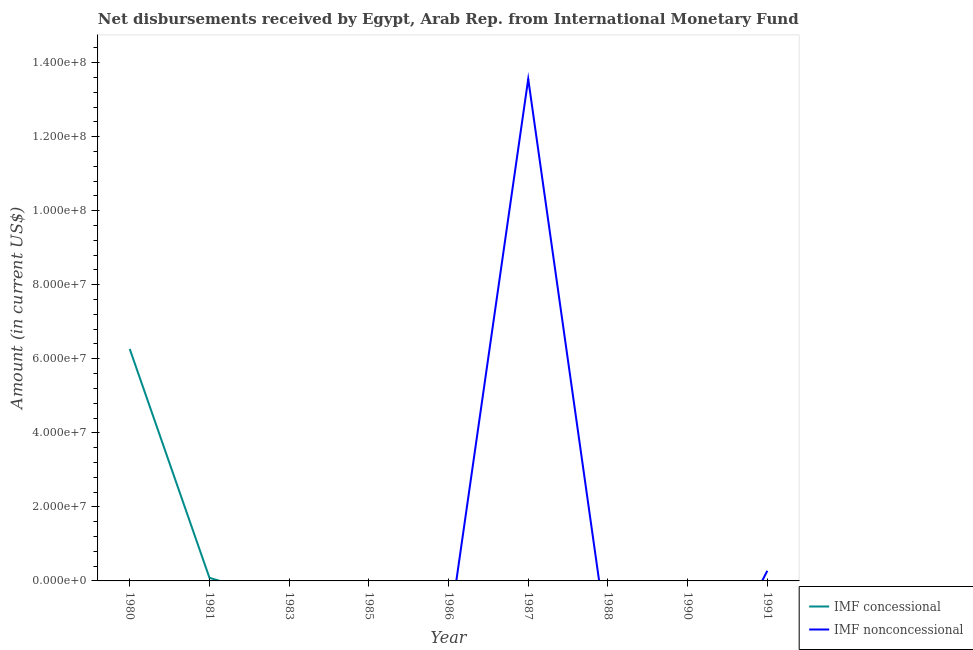Does the line corresponding to net concessional disbursements from imf intersect with the line corresponding to net non concessional disbursements from imf?
Keep it short and to the point. Yes. What is the net non concessional disbursements from imf in 1986?
Ensure brevity in your answer.  0. Across all years, what is the maximum net concessional disbursements from imf?
Your answer should be very brief. 6.26e+07. In which year was the net concessional disbursements from imf maximum?
Your response must be concise. 1980. What is the total net non concessional disbursements from imf in the graph?
Your answer should be compact. 1.38e+08. What is the difference between the net concessional disbursements from imf in 1980 and the net non concessional disbursements from imf in 1990?
Your response must be concise. 6.26e+07. What is the average net concessional disbursements from imf per year?
Your answer should be very brief. 7.05e+06. What is the difference between the highest and the lowest net concessional disbursements from imf?
Offer a very short reply. 6.26e+07. In how many years, is the net non concessional disbursements from imf greater than the average net non concessional disbursements from imf taken over all years?
Provide a short and direct response. 1. Does the net concessional disbursements from imf monotonically increase over the years?
Make the answer very short. No. Is the net concessional disbursements from imf strictly greater than the net non concessional disbursements from imf over the years?
Keep it short and to the point. No. Is the net concessional disbursements from imf strictly less than the net non concessional disbursements from imf over the years?
Provide a succinct answer. No. How many lines are there?
Provide a short and direct response. 2. Does the graph contain any zero values?
Your answer should be compact. Yes. Does the graph contain grids?
Your answer should be compact. No. What is the title of the graph?
Offer a terse response. Net disbursements received by Egypt, Arab Rep. from International Monetary Fund. What is the label or title of the X-axis?
Keep it short and to the point. Year. What is the label or title of the Y-axis?
Offer a very short reply. Amount (in current US$). What is the Amount (in current US$) of IMF concessional in 1980?
Provide a succinct answer. 6.26e+07. What is the Amount (in current US$) in IMF nonconcessional in 1980?
Your response must be concise. 0. What is the Amount (in current US$) of IMF concessional in 1981?
Offer a very short reply. 8.38e+05. What is the Amount (in current US$) in IMF nonconcessional in 1981?
Keep it short and to the point. 0. What is the Amount (in current US$) of IMF concessional in 1983?
Offer a very short reply. 0. What is the Amount (in current US$) in IMF concessional in 1985?
Provide a succinct answer. 0. What is the Amount (in current US$) of IMF concessional in 1986?
Offer a very short reply. 0. What is the Amount (in current US$) in IMF nonconcessional in 1987?
Offer a very short reply. 1.36e+08. What is the Amount (in current US$) of IMF nonconcessional in 1988?
Provide a short and direct response. 0. What is the Amount (in current US$) of IMF concessional in 1991?
Offer a very short reply. 0. What is the Amount (in current US$) of IMF nonconcessional in 1991?
Your answer should be very brief. 2.74e+06. Across all years, what is the maximum Amount (in current US$) of IMF concessional?
Offer a terse response. 6.26e+07. Across all years, what is the maximum Amount (in current US$) of IMF nonconcessional?
Give a very brief answer. 1.36e+08. Across all years, what is the minimum Amount (in current US$) of IMF concessional?
Provide a short and direct response. 0. Across all years, what is the minimum Amount (in current US$) of IMF nonconcessional?
Make the answer very short. 0. What is the total Amount (in current US$) of IMF concessional in the graph?
Offer a very short reply. 6.35e+07. What is the total Amount (in current US$) in IMF nonconcessional in the graph?
Offer a terse response. 1.38e+08. What is the difference between the Amount (in current US$) of IMF concessional in 1980 and that in 1981?
Offer a very short reply. 6.18e+07. What is the difference between the Amount (in current US$) of IMF nonconcessional in 1987 and that in 1991?
Your answer should be compact. 1.33e+08. What is the difference between the Amount (in current US$) of IMF concessional in 1980 and the Amount (in current US$) of IMF nonconcessional in 1987?
Ensure brevity in your answer.  -7.29e+07. What is the difference between the Amount (in current US$) in IMF concessional in 1980 and the Amount (in current US$) in IMF nonconcessional in 1991?
Provide a succinct answer. 5.99e+07. What is the difference between the Amount (in current US$) of IMF concessional in 1981 and the Amount (in current US$) of IMF nonconcessional in 1987?
Keep it short and to the point. -1.35e+08. What is the difference between the Amount (in current US$) of IMF concessional in 1981 and the Amount (in current US$) of IMF nonconcessional in 1991?
Provide a succinct answer. -1.90e+06. What is the average Amount (in current US$) in IMF concessional per year?
Your answer should be compact. 7.05e+06. What is the average Amount (in current US$) in IMF nonconcessional per year?
Offer a terse response. 1.54e+07. What is the ratio of the Amount (in current US$) in IMF concessional in 1980 to that in 1981?
Provide a succinct answer. 74.75. What is the ratio of the Amount (in current US$) of IMF nonconcessional in 1987 to that in 1991?
Your response must be concise. 49.53. What is the difference between the highest and the lowest Amount (in current US$) of IMF concessional?
Your response must be concise. 6.26e+07. What is the difference between the highest and the lowest Amount (in current US$) in IMF nonconcessional?
Your answer should be compact. 1.36e+08. 